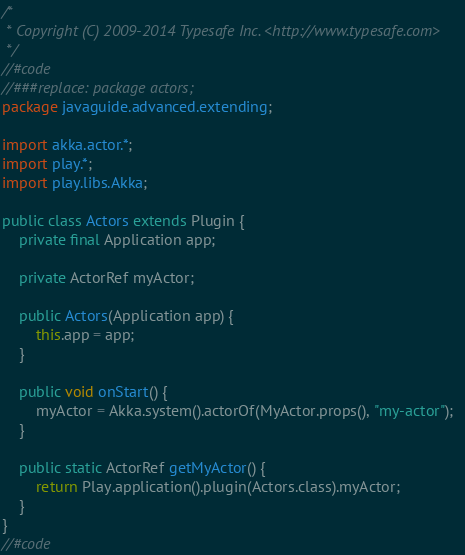<code> <loc_0><loc_0><loc_500><loc_500><_Java_>/*
 * Copyright (C) 2009-2014 Typesafe Inc. <http://www.typesafe.com>
 */
//#code
//###replace: package actors;
package javaguide.advanced.extending;

import akka.actor.*;
import play.*;
import play.libs.Akka;

public class Actors extends Plugin {
    private final Application app;

    private ActorRef myActor;

    public Actors(Application app) {
        this.app = app;
    }

    public void onStart() {
        myActor = Akka.system().actorOf(MyActor.props(), "my-actor");
    }

    public static ActorRef getMyActor() {
        return Play.application().plugin(Actors.class).myActor;
    }
}
//#code
</code> 